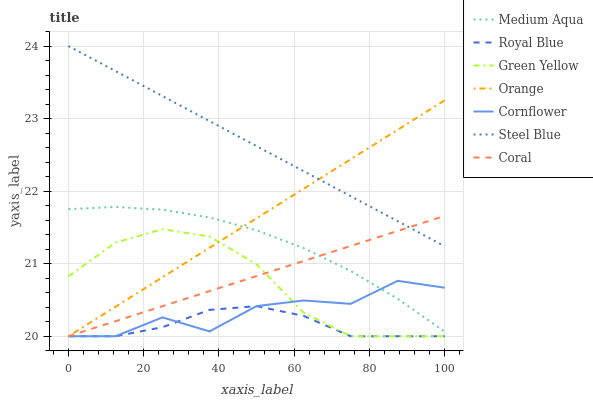Does Royal Blue have the minimum area under the curve?
Answer yes or no. Yes. Does Steel Blue have the maximum area under the curve?
Answer yes or no. Yes. Does Coral have the minimum area under the curve?
Answer yes or no. No. Does Coral have the maximum area under the curve?
Answer yes or no. No. Is Steel Blue the smoothest?
Answer yes or no. Yes. Is Cornflower the roughest?
Answer yes or no. Yes. Is Coral the smoothest?
Answer yes or no. No. Is Coral the roughest?
Answer yes or no. No. Does Cornflower have the lowest value?
Answer yes or no. Yes. Does Steel Blue have the lowest value?
Answer yes or no. No. Does Steel Blue have the highest value?
Answer yes or no. Yes. Does Coral have the highest value?
Answer yes or no. No. Is Green Yellow less than Medium Aqua?
Answer yes or no. Yes. Is Steel Blue greater than Medium Aqua?
Answer yes or no. Yes. Does Coral intersect Cornflower?
Answer yes or no. Yes. Is Coral less than Cornflower?
Answer yes or no. No. Is Coral greater than Cornflower?
Answer yes or no. No. Does Green Yellow intersect Medium Aqua?
Answer yes or no. No. 